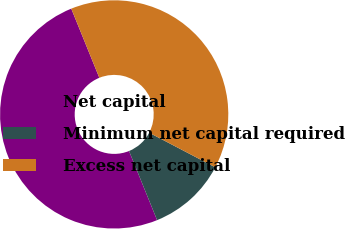<chart> <loc_0><loc_0><loc_500><loc_500><pie_chart><fcel>Net capital<fcel>Minimum net capital required<fcel>Excess net capital<nl><fcel>50.0%<fcel>11.19%<fcel>38.81%<nl></chart> 